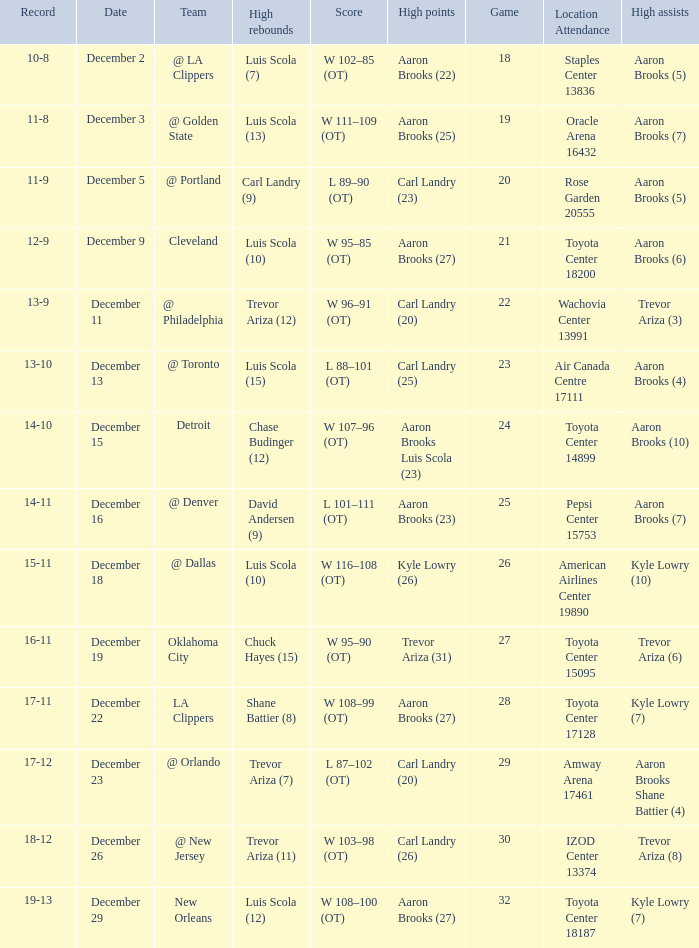Who did the high rebounds in the game where Carl Landry (23) did the most high points? Carl Landry (9). 